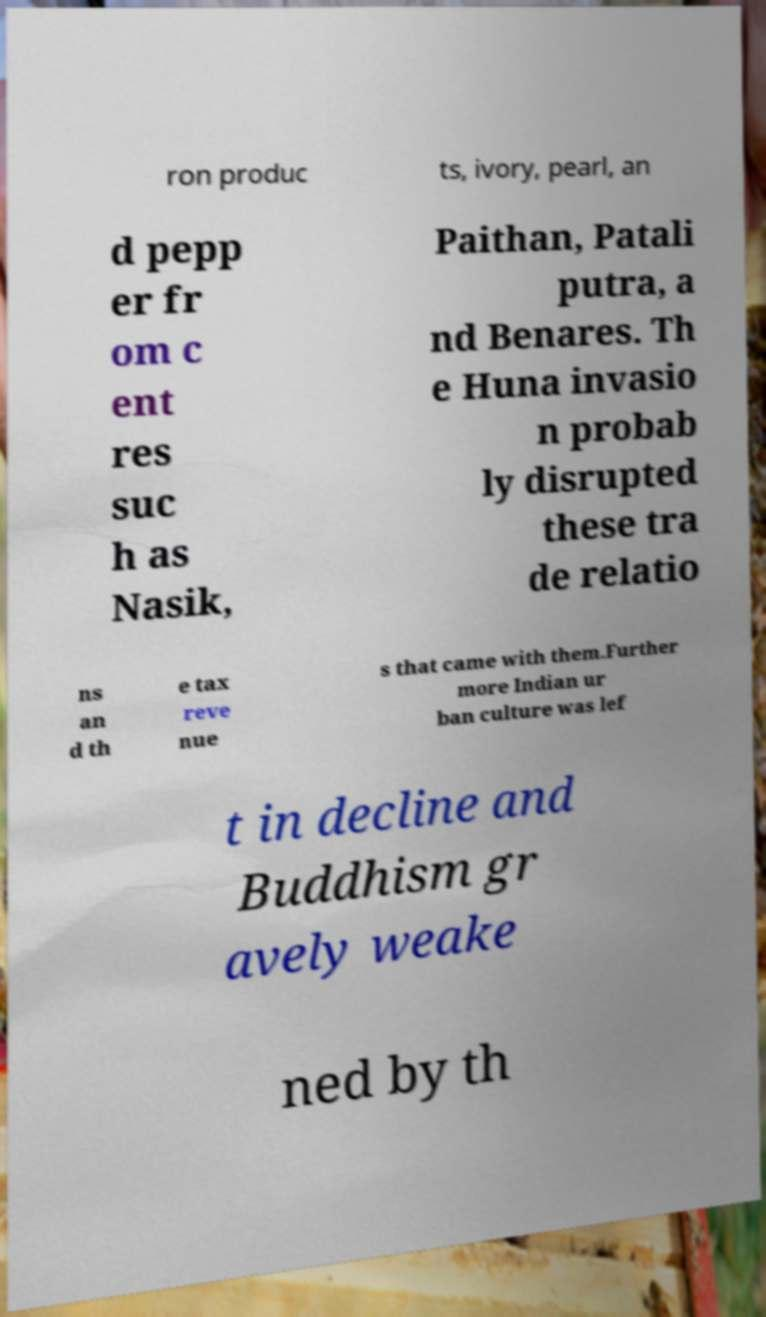Can you accurately transcribe the text from the provided image for me? ron produc ts, ivory, pearl, an d pepp er fr om c ent res suc h as Nasik, Paithan, Patali putra, a nd Benares. Th e Huna invasio n probab ly disrupted these tra de relatio ns an d th e tax reve nue s that came with them.Further more Indian ur ban culture was lef t in decline and Buddhism gr avely weake ned by th 